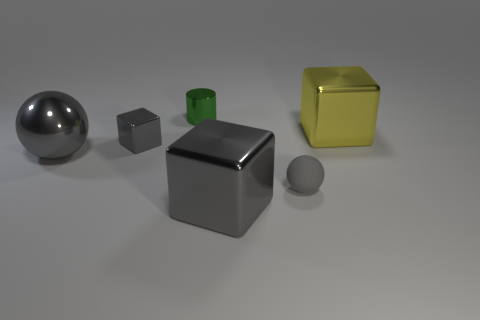Subtract all gray metallic blocks. How many blocks are left? 1 Add 1 matte spheres. How many objects exist? 7 Subtract 2 spheres. How many spheres are left? 0 Subtract all balls. How many objects are left? 4 Subtract all yellow balls. Subtract all gray cubes. How many balls are left? 2 Subtract all red cylinders. How many red balls are left? 0 Subtract all green cylinders. Subtract all big shiny blocks. How many objects are left? 3 Add 5 tiny metal blocks. How many tiny metal blocks are left? 6 Add 2 red shiny balls. How many red shiny balls exist? 2 Subtract all gray blocks. How many blocks are left? 1 